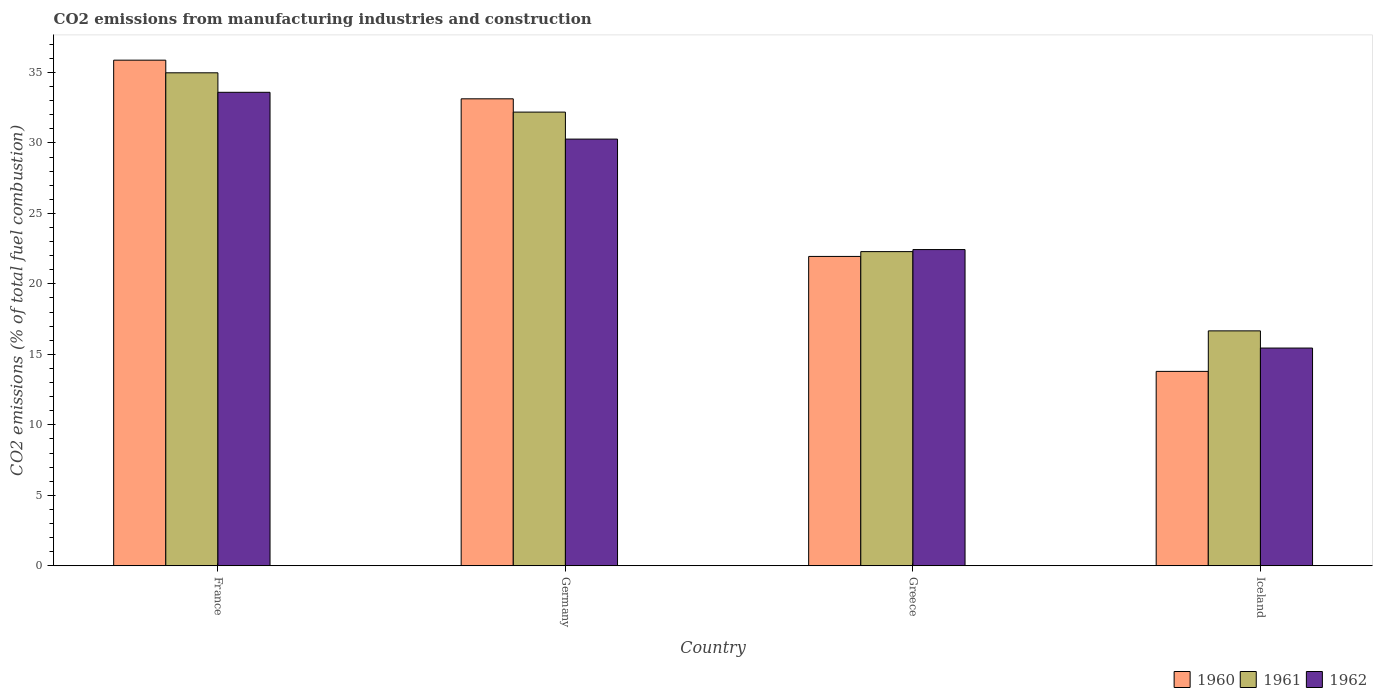How many different coloured bars are there?
Your answer should be very brief. 3. How many groups of bars are there?
Your response must be concise. 4. Are the number of bars per tick equal to the number of legend labels?
Offer a very short reply. Yes. How many bars are there on the 2nd tick from the left?
Provide a succinct answer. 3. How many bars are there on the 4th tick from the right?
Your answer should be compact. 3. What is the label of the 4th group of bars from the left?
Your answer should be compact. Iceland. In how many cases, is the number of bars for a given country not equal to the number of legend labels?
Your response must be concise. 0. What is the amount of CO2 emitted in 1962 in France?
Give a very brief answer. 33.59. Across all countries, what is the maximum amount of CO2 emitted in 1962?
Offer a terse response. 33.59. Across all countries, what is the minimum amount of CO2 emitted in 1962?
Make the answer very short. 15.45. What is the total amount of CO2 emitted in 1962 in the graph?
Your answer should be compact. 101.75. What is the difference between the amount of CO2 emitted in 1961 in France and that in Germany?
Make the answer very short. 2.79. What is the difference between the amount of CO2 emitted in 1962 in Iceland and the amount of CO2 emitted in 1960 in France?
Give a very brief answer. -20.43. What is the average amount of CO2 emitted in 1962 per country?
Make the answer very short. 25.44. What is the difference between the amount of CO2 emitted of/in 1962 and amount of CO2 emitted of/in 1961 in France?
Your answer should be compact. -1.38. In how many countries, is the amount of CO2 emitted in 1960 greater than 16 %?
Offer a terse response. 3. What is the ratio of the amount of CO2 emitted in 1961 in Germany to that in Iceland?
Keep it short and to the point. 1.93. Is the amount of CO2 emitted in 1961 in Greece less than that in Iceland?
Your answer should be compact. No. Is the difference between the amount of CO2 emitted in 1962 in Germany and Greece greater than the difference between the amount of CO2 emitted in 1961 in Germany and Greece?
Offer a very short reply. No. What is the difference between the highest and the second highest amount of CO2 emitted in 1961?
Your answer should be compact. -2.79. What is the difference between the highest and the lowest amount of CO2 emitted in 1960?
Offer a very short reply. 22.08. In how many countries, is the amount of CO2 emitted in 1962 greater than the average amount of CO2 emitted in 1962 taken over all countries?
Your response must be concise. 2. What does the 3rd bar from the left in Germany represents?
Make the answer very short. 1962. Is it the case that in every country, the sum of the amount of CO2 emitted in 1960 and amount of CO2 emitted in 1961 is greater than the amount of CO2 emitted in 1962?
Keep it short and to the point. Yes. How many bars are there?
Your answer should be very brief. 12. Are the values on the major ticks of Y-axis written in scientific E-notation?
Your answer should be compact. No. How are the legend labels stacked?
Your answer should be very brief. Horizontal. What is the title of the graph?
Provide a succinct answer. CO2 emissions from manufacturing industries and construction. What is the label or title of the Y-axis?
Offer a terse response. CO2 emissions (% of total fuel combustion). What is the CO2 emissions (% of total fuel combustion) in 1960 in France?
Provide a short and direct response. 35.87. What is the CO2 emissions (% of total fuel combustion) in 1961 in France?
Provide a short and direct response. 34.98. What is the CO2 emissions (% of total fuel combustion) in 1962 in France?
Offer a terse response. 33.59. What is the CO2 emissions (% of total fuel combustion) of 1960 in Germany?
Provide a short and direct response. 33.13. What is the CO2 emissions (% of total fuel combustion) of 1961 in Germany?
Provide a succinct answer. 32.19. What is the CO2 emissions (% of total fuel combustion) of 1962 in Germany?
Your answer should be very brief. 30.27. What is the CO2 emissions (% of total fuel combustion) in 1960 in Greece?
Your answer should be compact. 21.95. What is the CO2 emissions (% of total fuel combustion) in 1961 in Greece?
Provide a succinct answer. 22.29. What is the CO2 emissions (% of total fuel combustion) in 1962 in Greece?
Ensure brevity in your answer.  22.44. What is the CO2 emissions (% of total fuel combustion) of 1960 in Iceland?
Ensure brevity in your answer.  13.79. What is the CO2 emissions (% of total fuel combustion) in 1961 in Iceland?
Give a very brief answer. 16.67. What is the CO2 emissions (% of total fuel combustion) of 1962 in Iceland?
Ensure brevity in your answer.  15.45. Across all countries, what is the maximum CO2 emissions (% of total fuel combustion) in 1960?
Offer a very short reply. 35.87. Across all countries, what is the maximum CO2 emissions (% of total fuel combustion) in 1961?
Keep it short and to the point. 34.98. Across all countries, what is the maximum CO2 emissions (% of total fuel combustion) of 1962?
Your answer should be very brief. 33.59. Across all countries, what is the minimum CO2 emissions (% of total fuel combustion) of 1960?
Give a very brief answer. 13.79. Across all countries, what is the minimum CO2 emissions (% of total fuel combustion) in 1961?
Make the answer very short. 16.67. Across all countries, what is the minimum CO2 emissions (% of total fuel combustion) of 1962?
Make the answer very short. 15.45. What is the total CO2 emissions (% of total fuel combustion) of 1960 in the graph?
Make the answer very short. 104.74. What is the total CO2 emissions (% of total fuel combustion) of 1961 in the graph?
Your answer should be compact. 106.12. What is the total CO2 emissions (% of total fuel combustion) in 1962 in the graph?
Your answer should be very brief. 101.75. What is the difference between the CO2 emissions (% of total fuel combustion) of 1960 in France and that in Germany?
Make the answer very short. 2.74. What is the difference between the CO2 emissions (% of total fuel combustion) of 1961 in France and that in Germany?
Your response must be concise. 2.79. What is the difference between the CO2 emissions (% of total fuel combustion) of 1962 in France and that in Germany?
Ensure brevity in your answer.  3.32. What is the difference between the CO2 emissions (% of total fuel combustion) in 1960 in France and that in Greece?
Your answer should be very brief. 13.92. What is the difference between the CO2 emissions (% of total fuel combustion) in 1961 in France and that in Greece?
Make the answer very short. 12.69. What is the difference between the CO2 emissions (% of total fuel combustion) in 1962 in France and that in Greece?
Your response must be concise. 11.16. What is the difference between the CO2 emissions (% of total fuel combustion) in 1960 in France and that in Iceland?
Your answer should be very brief. 22.08. What is the difference between the CO2 emissions (% of total fuel combustion) of 1961 in France and that in Iceland?
Ensure brevity in your answer.  18.31. What is the difference between the CO2 emissions (% of total fuel combustion) of 1962 in France and that in Iceland?
Make the answer very short. 18.14. What is the difference between the CO2 emissions (% of total fuel combustion) in 1960 in Germany and that in Greece?
Offer a very short reply. 11.18. What is the difference between the CO2 emissions (% of total fuel combustion) in 1961 in Germany and that in Greece?
Provide a succinct answer. 9.9. What is the difference between the CO2 emissions (% of total fuel combustion) of 1962 in Germany and that in Greece?
Your response must be concise. 7.84. What is the difference between the CO2 emissions (% of total fuel combustion) in 1960 in Germany and that in Iceland?
Offer a terse response. 19.34. What is the difference between the CO2 emissions (% of total fuel combustion) in 1961 in Germany and that in Iceland?
Ensure brevity in your answer.  15.52. What is the difference between the CO2 emissions (% of total fuel combustion) in 1962 in Germany and that in Iceland?
Your answer should be very brief. 14.82. What is the difference between the CO2 emissions (% of total fuel combustion) in 1960 in Greece and that in Iceland?
Your response must be concise. 8.15. What is the difference between the CO2 emissions (% of total fuel combustion) of 1961 in Greece and that in Iceland?
Provide a short and direct response. 5.62. What is the difference between the CO2 emissions (% of total fuel combustion) in 1962 in Greece and that in Iceland?
Your answer should be compact. 6.99. What is the difference between the CO2 emissions (% of total fuel combustion) in 1960 in France and the CO2 emissions (% of total fuel combustion) in 1961 in Germany?
Your answer should be very brief. 3.68. What is the difference between the CO2 emissions (% of total fuel combustion) in 1960 in France and the CO2 emissions (% of total fuel combustion) in 1962 in Germany?
Offer a terse response. 5.6. What is the difference between the CO2 emissions (% of total fuel combustion) of 1961 in France and the CO2 emissions (% of total fuel combustion) of 1962 in Germany?
Your answer should be very brief. 4.7. What is the difference between the CO2 emissions (% of total fuel combustion) in 1960 in France and the CO2 emissions (% of total fuel combustion) in 1961 in Greece?
Your response must be concise. 13.58. What is the difference between the CO2 emissions (% of total fuel combustion) in 1960 in France and the CO2 emissions (% of total fuel combustion) in 1962 in Greece?
Give a very brief answer. 13.44. What is the difference between the CO2 emissions (% of total fuel combustion) of 1961 in France and the CO2 emissions (% of total fuel combustion) of 1962 in Greece?
Keep it short and to the point. 12.54. What is the difference between the CO2 emissions (% of total fuel combustion) of 1960 in France and the CO2 emissions (% of total fuel combustion) of 1961 in Iceland?
Your answer should be compact. 19.21. What is the difference between the CO2 emissions (% of total fuel combustion) in 1960 in France and the CO2 emissions (% of total fuel combustion) in 1962 in Iceland?
Keep it short and to the point. 20.43. What is the difference between the CO2 emissions (% of total fuel combustion) of 1961 in France and the CO2 emissions (% of total fuel combustion) of 1962 in Iceland?
Offer a very short reply. 19.53. What is the difference between the CO2 emissions (% of total fuel combustion) of 1960 in Germany and the CO2 emissions (% of total fuel combustion) of 1961 in Greece?
Give a very brief answer. 10.84. What is the difference between the CO2 emissions (% of total fuel combustion) in 1960 in Germany and the CO2 emissions (% of total fuel combustion) in 1962 in Greece?
Your answer should be compact. 10.69. What is the difference between the CO2 emissions (% of total fuel combustion) of 1961 in Germany and the CO2 emissions (% of total fuel combustion) of 1962 in Greece?
Keep it short and to the point. 9.75. What is the difference between the CO2 emissions (% of total fuel combustion) of 1960 in Germany and the CO2 emissions (% of total fuel combustion) of 1961 in Iceland?
Keep it short and to the point. 16.46. What is the difference between the CO2 emissions (% of total fuel combustion) in 1960 in Germany and the CO2 emissions (% of total fuel combustion) in 1962 in Iceland?
Offer a terse response. 17.68. What is the difference between the CO2 emissions (% of total fuel combustion) of 1961 in Germany and the CO2 emissions (% of total fuel combustion) of 1962 in Iceland?
Make the answer very short. 16.74. What is the difference between the CO2 emissions (% of total fuel combustion) of 1960 in Greece and the CO2 emissions (% of total fuel combustion) of 1961 in Iceland?
Provide a short and direct response. 5.28. What is the difference between the CO2 emissions (% of total fuel combustion) in 1960 in Greece and the CO2 emissions (% of total fuel combustion) in 1962 in Iceland?
Provide a short and direct response. 6.5. What is the difference between the CO2 emissions (% of total fuel combustion) of 1961 in Greece and the CO2 emissions (% of total fuel combustion) of 1962 in Iceland?
Offer a terse response. 6.84. What is the average CO2 emissions (% of total fuel combustion) of 1960 per country?
Offer a very short reply. 26.19. What is the average CO2 emissions (% of total fuel combustion) in 1961 per country?
Offer a very short reply. 26.53. What is the average CO2 emissions (% of total fuel combustion) of 1962 per country?
Your answer should be compact. 25.44. What is the difference between the CO2 emissions (% of total fuel combustion) in 1960 and CO2 emissions (% of total fuel combustion) in 1961 in France?
Give a very brief answer. 0.9. What is the difference between the CO2 emissions (% of total fuel combustion) in 1960 and CO2 emissions (% of total fuel combustion) in 1962 in France?
Ensure brevity in your answer.  2.28. What is the difference between the CO2 emissions (% of total fuel combustion) of 1961 and CO2 emissions (% of total fuel combustion) of 1962 in France?
Your answer should be very brief. 1.38. What is the difference between the CO2 emissions (% of total fuel combustion) of 1960 and CO2 emissions (% of total fuel combustion) of 1961 in Germany?
Provide a succinct answer. 0.94. What is the difference between the CO2 emissions (% of total fuel combustion) of 1960 and CO2 emissions (% of total fuel combustion) of 1962 in Germany?
Your answer should be very brief. 2.86. What is the difference between the CO2 emissions (% of total fuel combustion) of 1961 and CO2 emissions (% of total fuel combustion) of 1962 in Germany?
Provide a succinct answer. 1.92. What is the difference between the CO2 emissions (% of total fuel combustion) in 1960 and CO2 emissions (% of total fuel combustion) in 1961 in Greece?
Your answer should be compact. -0.34. What is the difference between the CO2 emissions (% of total fuel combustion) of 1960 and CO2 emissions (% of total fuel combustion) of 1962 in Greece?
Your answer should be very brief. -0.49. What is the difference between the CO2 emissions (% of total fuel combustion) in 1961 and CO2 emissions (% of total fuel combustion) in 1962 in Greece?
Offer a very short reply. -0.15. What is the difference between the CO2 emissions (% of total fuel combustion) of 1960 and CO2 emissions (% of total fuel combustion) of 1961 in Iceland?
Offer a terse response. -2.87. What is the difference between the CO2 emissions (% of total fuel combustion) of 1960 and CO2 emissions (% of total fuel combustion) of 1962 in Iceland?
Give a very brief answer. -1.65. What is the difference between the CO2 emissions (% of total fuel combustion) in 1961 and CO2 emissions (% of total fuel combustion) in 1962 in Iceland?
Make the answer very short. 1.22. What is the ratio of the CO2 emissions (% of total fuel combustion) in 1960 in France to that in Germany?
Offer a terse response. 1.08. What is the ratio of the CO2 emissions (% of total fuel combustion) of 1961 in France to that in Germany?
Ensure brevity in your answer.  1.09. What is the ratio of the CO2 emissions (% of total fuel combustion) of 1962 in France to that in Germany?
Your response must be concise. 1.11. What is the ratio of the CO2 emissions (% of total fuel combustion) of 1960 in France to that in Greece?
Provide a succinct answer. 1.63. What is the ratio of the CO2 emissions (% of total fuel combustion) in 1961 in France to that in Greece?
Ensure brevity in your answer.  1.57. What is the ratio of the CO2 emissions (% of total fuel combustion) in 1962 in France to that in Greece?
Provide a succinct answer. 1.5. What is the ratio of the CO2 emissions (% of total fuel combustion) of 1960 in France to that in Iceland?
Your response must be concise. 2.6. What is the ratio of the CO2 emissions (% of total fuel combustion) of 1961 in France to that in Iceland?
Provide a succinct answer. 2.1. What is the ratio of the CO2 emissions (% of total fuel combustion) in 1962 in France to that in Iceland?
Provide a succinct answer. 2.17. What is the ratio of the CO2 emissions (% of total fuel combustion) of 1960 in Germany to that in Greece?
Your answer should be very brief. 1.51. What is the ratio of the CO2 emissions (% of total fuel combustion) in 1961 in Germany to that in Greece?
Offer a very short reply. 1.44. What is the ratio of the CO2 emissions (% of total fuel combustion) in 1962 in Germany to that in Greece?
Your response must be concise. 1.35. What is the ratio of the CO2 emissions (% of total fuel combustion) of 1960 in Germany to that in Iceland?
Your answer should be compact. 2.4. What is the ratio of the CO2 emissions (% of total fuel combustion) in 1961 in Germany to that in Iceland?
Provide a succinct answer. 1.93. What is the ratio of the CO2 emissions (% of total fuel combustion) in 1962 in Germany to that in Iceland?
Provide a succinct answer. 1.96. What is the ratio of the CO2 emissions (% of total fuel combustion) in 1960 in Greece to that in Iceland?
Keep it short and to the point. 1.59. What is the ratio of the CO2 emissions (% of total fuel combustion) in 1961 in Greece to that in Iceland?
Your answer should be compact. 1.34. What is the ratio of the CO2 emissions (% of total fuel combustion) in 1962 in Greece to that in Iceland?
Provide a short and direct response. 1.45. What is the difference between the highest and the second highest CO2 emissions (% of total fuel combustion) in 1960?
Offer a terse response. 2.74. What is the difference between the highest and the second highest CO2 emissions (% of total fuel combustion) of 1961?
Keep it short and to the point. 2.79. What is the difference between the highest and the second highest CO2 emissions (% of total fuel combustion) in 1962?
Give a very brief answer. 3.32. What is the difference between the highest and the lowest CO2 emissions (% of total fuel combustion) of 1960?
Your answer should be very brief. 22.08. What is the difference between the highest and the lowest CO2 emissions (% of total fuel combustion) of 1961?
Provide a short and direct response. 18.31. What is the difference between the highest and the lowest CO2 emissions (% of total fuel combustion) in 1962?
Ensure brevity in your answer.  18.14. 